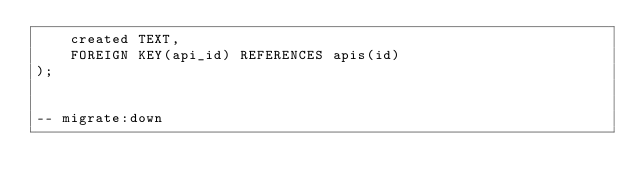<code> <loc_0><loc_0><loc_500><loc_500><_SQL_>    created TEXT,
    FOREIGN KEY(api_id) REFERENCES apis(id)
);


-- migrate:down

</code> 